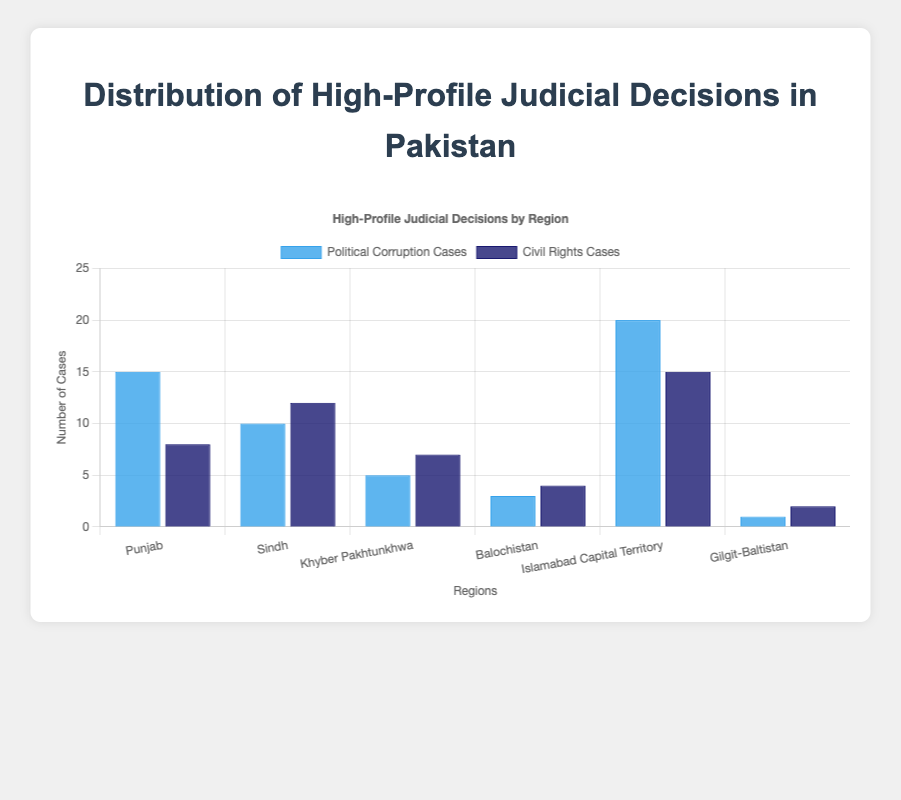What region has the highest number of political corruption cases? The region with the highest number of political corruption cases can be identified by comparing the heights of the blue bars. Islamabad Capital Territory has the highest blue bar, indicating it has the most cases.
Answer: Islamabad Capital Territory Which region has more civil rights cases compared to political corruption cases? To answer this, we compare the heights of the two bars for each region. Sindh has more civil rights cases (height of the dark blue bar) compared to political corruption cases (height of the blue bar).
Answer: Sindh What is the total number of high-profile cases (both political corruption and civil rights) in Punjab? Sum the heights of the blue and dark blue bars for Punjab. The number of political corruption cases is 15, and the number of civil rights cases is 8. Therefore, 15 + 8 = 23.
Answer: 23 How many more political corruption cases are there in Islamabad Capital Territory compared to Balochistan? Subtract the number of political corruption cases in Balochistan from Islamabad Capital Territory. The number in Islamabad Capital Territory is 20 and in Balochistan is 3. So, 20 - 3 = 17.
Answer: 17 Which region has the least number of high-profile judicial decisions in civil rights? Identify the region with the shortest dark blue bar. Gilgit-Baltistan has the least number of civil rights cases, indicated by the shortest dark blue bar.
Answer: Gilgit-Baltistan What is the difference in the total number of cases between Punjab and Sindh? Calculate the total number of cases for each region (for Punjab: 15 political corruption + 8 civil rights = 23; for Sindh: 10 political corruption + 12 civil rights = 22), then find the difference: 23 - 22 = 1.
Answer: 1 In which region do civil rights cases make up half or more of the total high-profile cases? For each region, check if the number of civil rights cases is at least half of the total high-profile cases. In Sindh: 12 civil rights cases out of 22 total cases (more than half).
Answer: Sindh What are the total number of high-profile judicial decisions in Gilgit-Baltistan? Sum the number of political corruption cases and civil rights cases for Gilgit-Baltistan. The numbers are 1 and 2 respectively, so 1 + 2 = 3.
Answer: 3 Which region has exactly 7 civil rights cases? Look for the region with a dark blue bar corresponding to 7 civil rights cases. Khyber Pakhtunkhwa has exactly 7 civil rights cases.
Answer: Khyber Pakhtunkhwa 